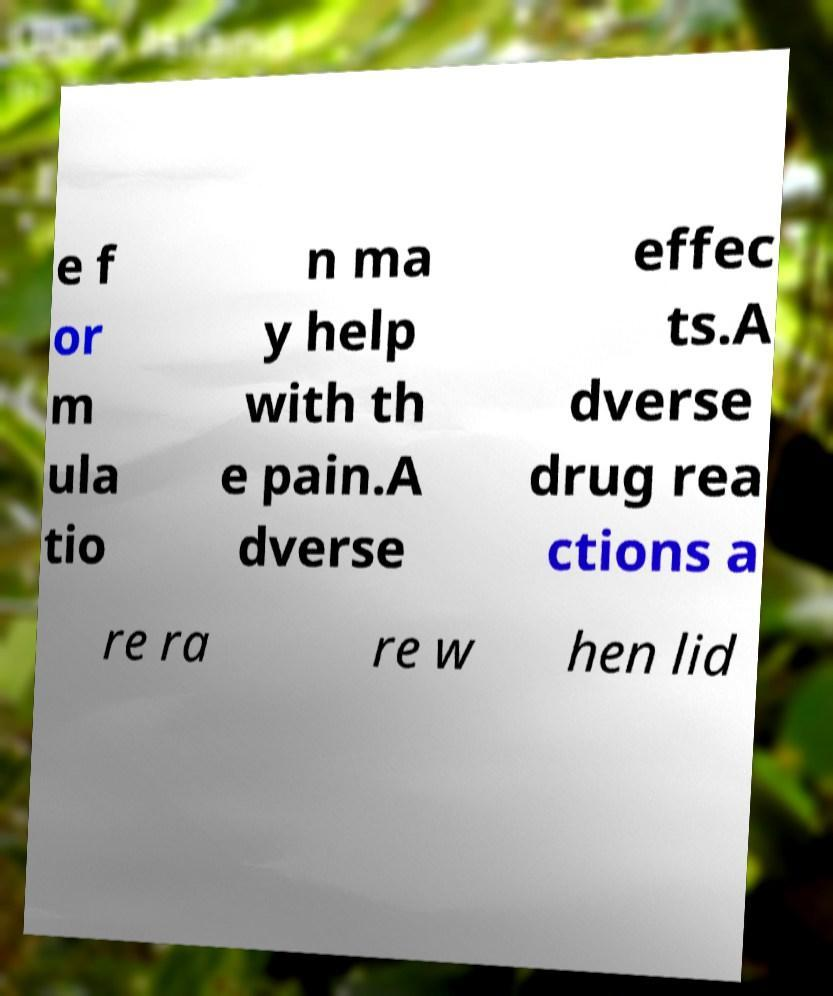Please read and relay the text visible in this image. What does it say? e f or m ula tio n ma y help with th e pain.A dverse effec ts.A dverse drug rea ctions a re ra re w hen lid 